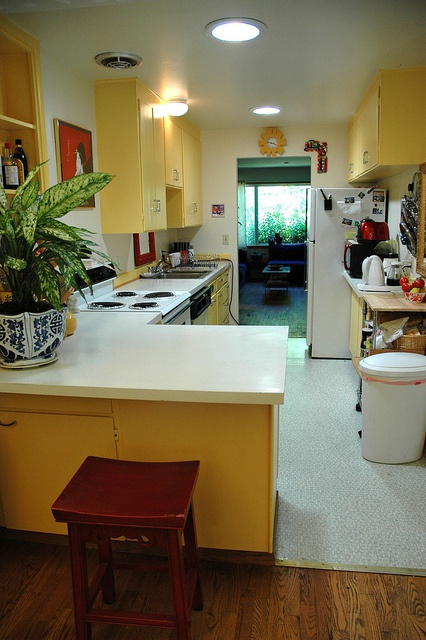Describe the objects in this image and their specific colors. I can see chair in black, maroon, and olive tones, potted plant in black, darkgreen, darkgray, and olive tones, refrigerator in black, darkgray, and gray tones, vase in black, darkgray, and gray tones, and oven in black, lightblue, and darkgray tones in this image. 